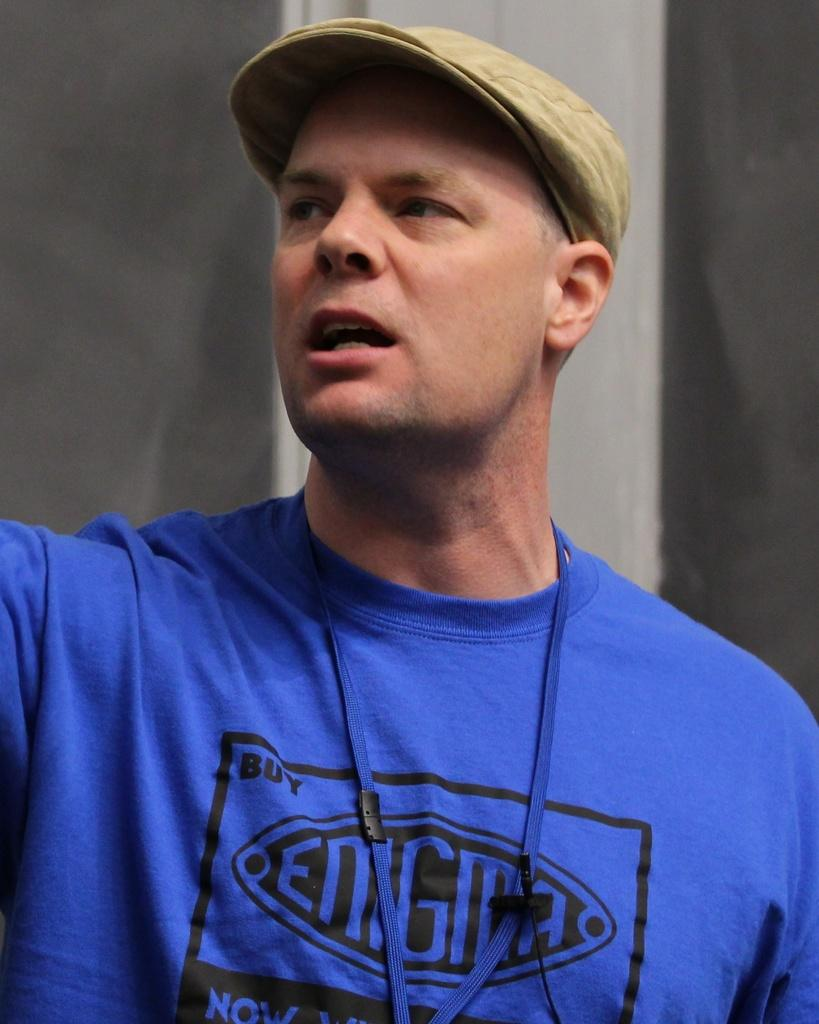<image>
Share a concise interpretation of the image provided. the word enigma is on the shirt of a man 